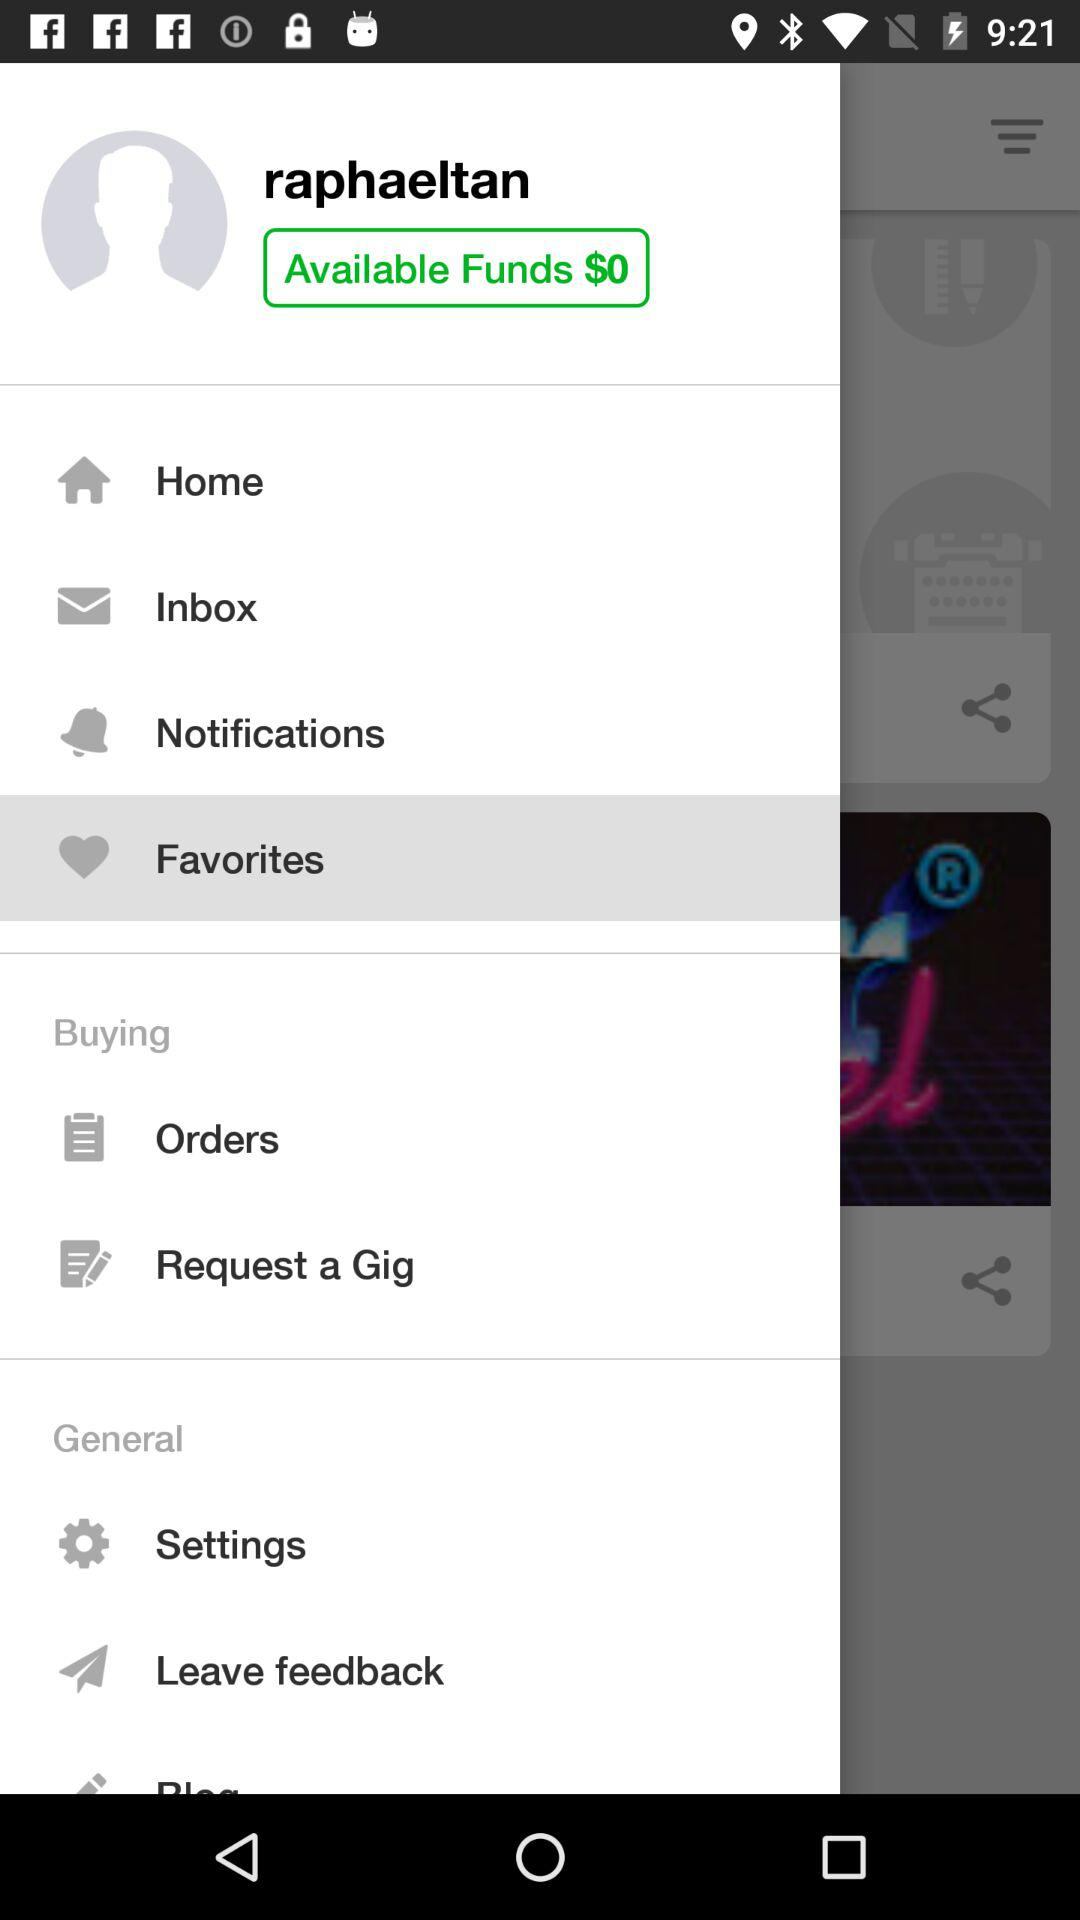Which tab is selected? The selected tab is "Favorites". 